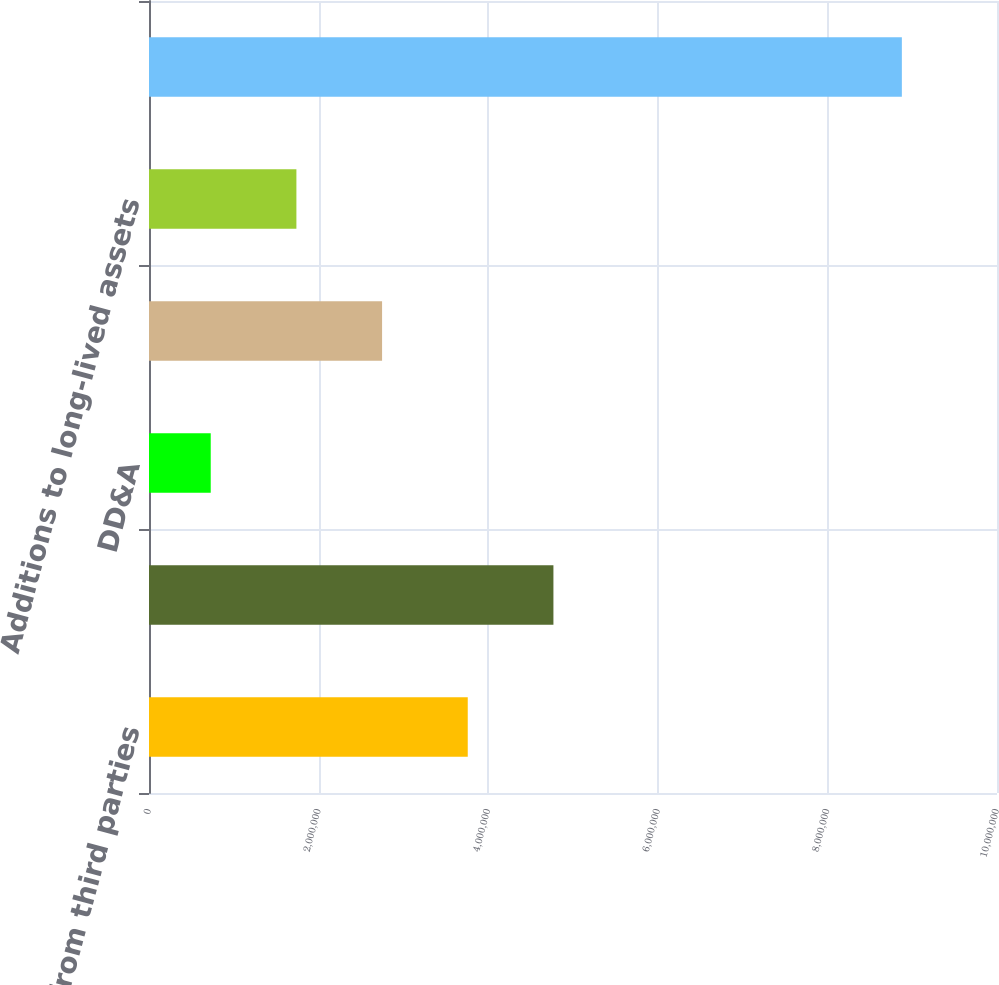Convert chart to OTSL. <chart><loc_0><loc_0><loc_500><loc_500><bar_chart><fcel>Revenues from third parties<fcel>Total Revenues<fcel>DD&A<fcel>Income (loss) before taxes<fcel>Additions to long-lived assets<fcel>Total assets at December 31<nl><fcel>3.75886e+06<fcel>4.76915e+06<fcel>727981<fcel>2.74856e+06<fcel>1.73827e+06<fcel>8.87803e+06<nl></chart> 